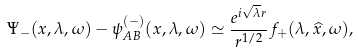Convert formula to latex. <formula><loc_0><loc_0><loc_500><loc_500>\Psi _ { - } ( x , \lambda , \omega ) - \psi _ { A B } ^ { ( - ) } ( x , \lambda , \omega ) \simeq \frac { e ^ { i \sqrt { \lambda } r } } { r ^ { 1 / 2 } } f _ { + } ( \lambda , \widehat { x } , \omega ) ,</formula> 